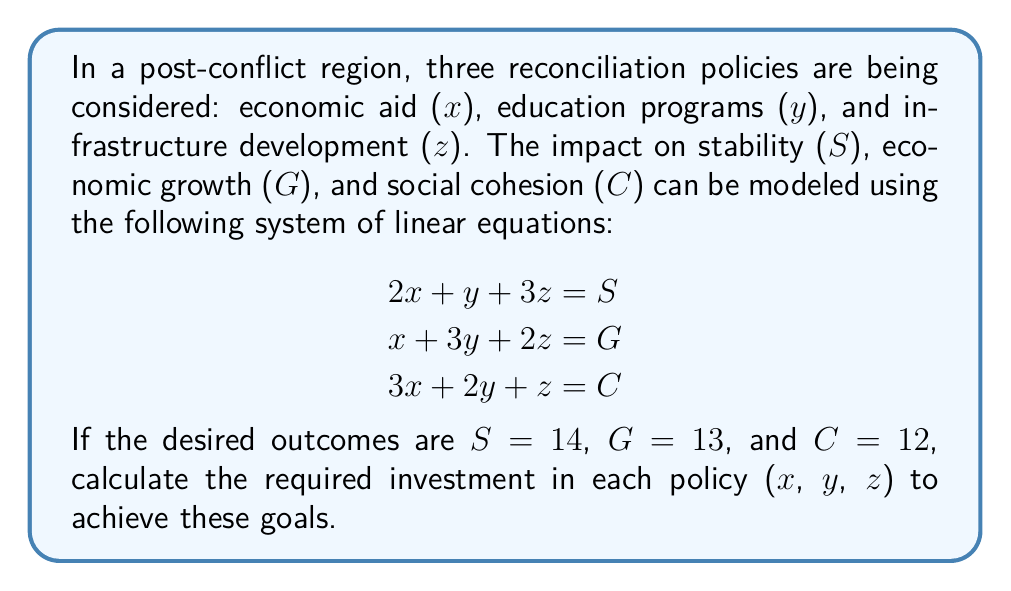Give your solution to this math problem. To solve this system of linear equations, we can use the Gaussian elimination method:

1. Write the augmented matrix:
   $$\begin{bmatrix}
   2 & 1 & 3 & 14 \\
   1 & 3 & 2 & 13 \\
   3 & 2 & 1 & 12
   \end{bmatrix}$$

2. Use row operations to transform the matrix into row echelon form:
   a. Multiply R1 by -1/2 and add to R2:
      $$\begin{bmatrix}
      2 & 1 & 3 & 14 \\
      0 & 5/2 & 1/2 & 6 \\
      3 & 2 & 1 & 12
      \end{bmatrix}$$
   
   b. Multiply R1 by -3/2 and add to R3:
      $$\begin{bmatrix}
      2 & 1 & 3 & 14 \\
      0 & 5/2 & 1/2 & 6 \\
      0 & 1/2 & -7/2 & -9
      \end{bmatrix}$$

3. Continue row operations to achieve reduced row echelon form:
   a. Multiply R2 by -1/5 and add to R3:
      $$\begin{bmatrix}
      2 & 1 & 3 & 14 \\
      0 & 5/2 & 1/2 & 6 \\
      0 & 0 & -15/4 & -12
      \end{bmatrix}$$

   b. Divide R3 by -15/4:
      $$\begin{bmatrix}
      2 & 1 & 3 & 14 \\
      0 & 5/2 & 1/2 & 6 \\
      0 & 0 & 1 & 16/5
      \end{bmatrix}$$

   c. Multiply R3 by -1/2 and add to R2:
      $$\begin{bmatrix}
      2 & 1 & 3 & 14 \\
      0 & 5/2 & 0 & 22/5 \\
      0 & 0 & 1 & 16/5
      \end{bmatrix}$$

   d. Multiply R3 by -3 and add to R1:
      $$\begin{bmatrix}
      2 & 1 & 0 & 2/5 \\
      0 & 5/2 & 0 & 22/5 \\
      0 & 0 & 1 & 16/5
      \end{bmatrix}$$

4. Solve for x, y, and z:
   z = 16/5
   y = (22/5) / (5/2) = 44/25
   x = (2/5 - 44/25) / 2 = 2/5

5. Convert fractions to decimals:
   x ≈ 0.4
   y ≈ 1.76
   z ≈ 3.2
Answer: x ≈ 0.4, y ≈ 1.76, z ≈ 3.2 